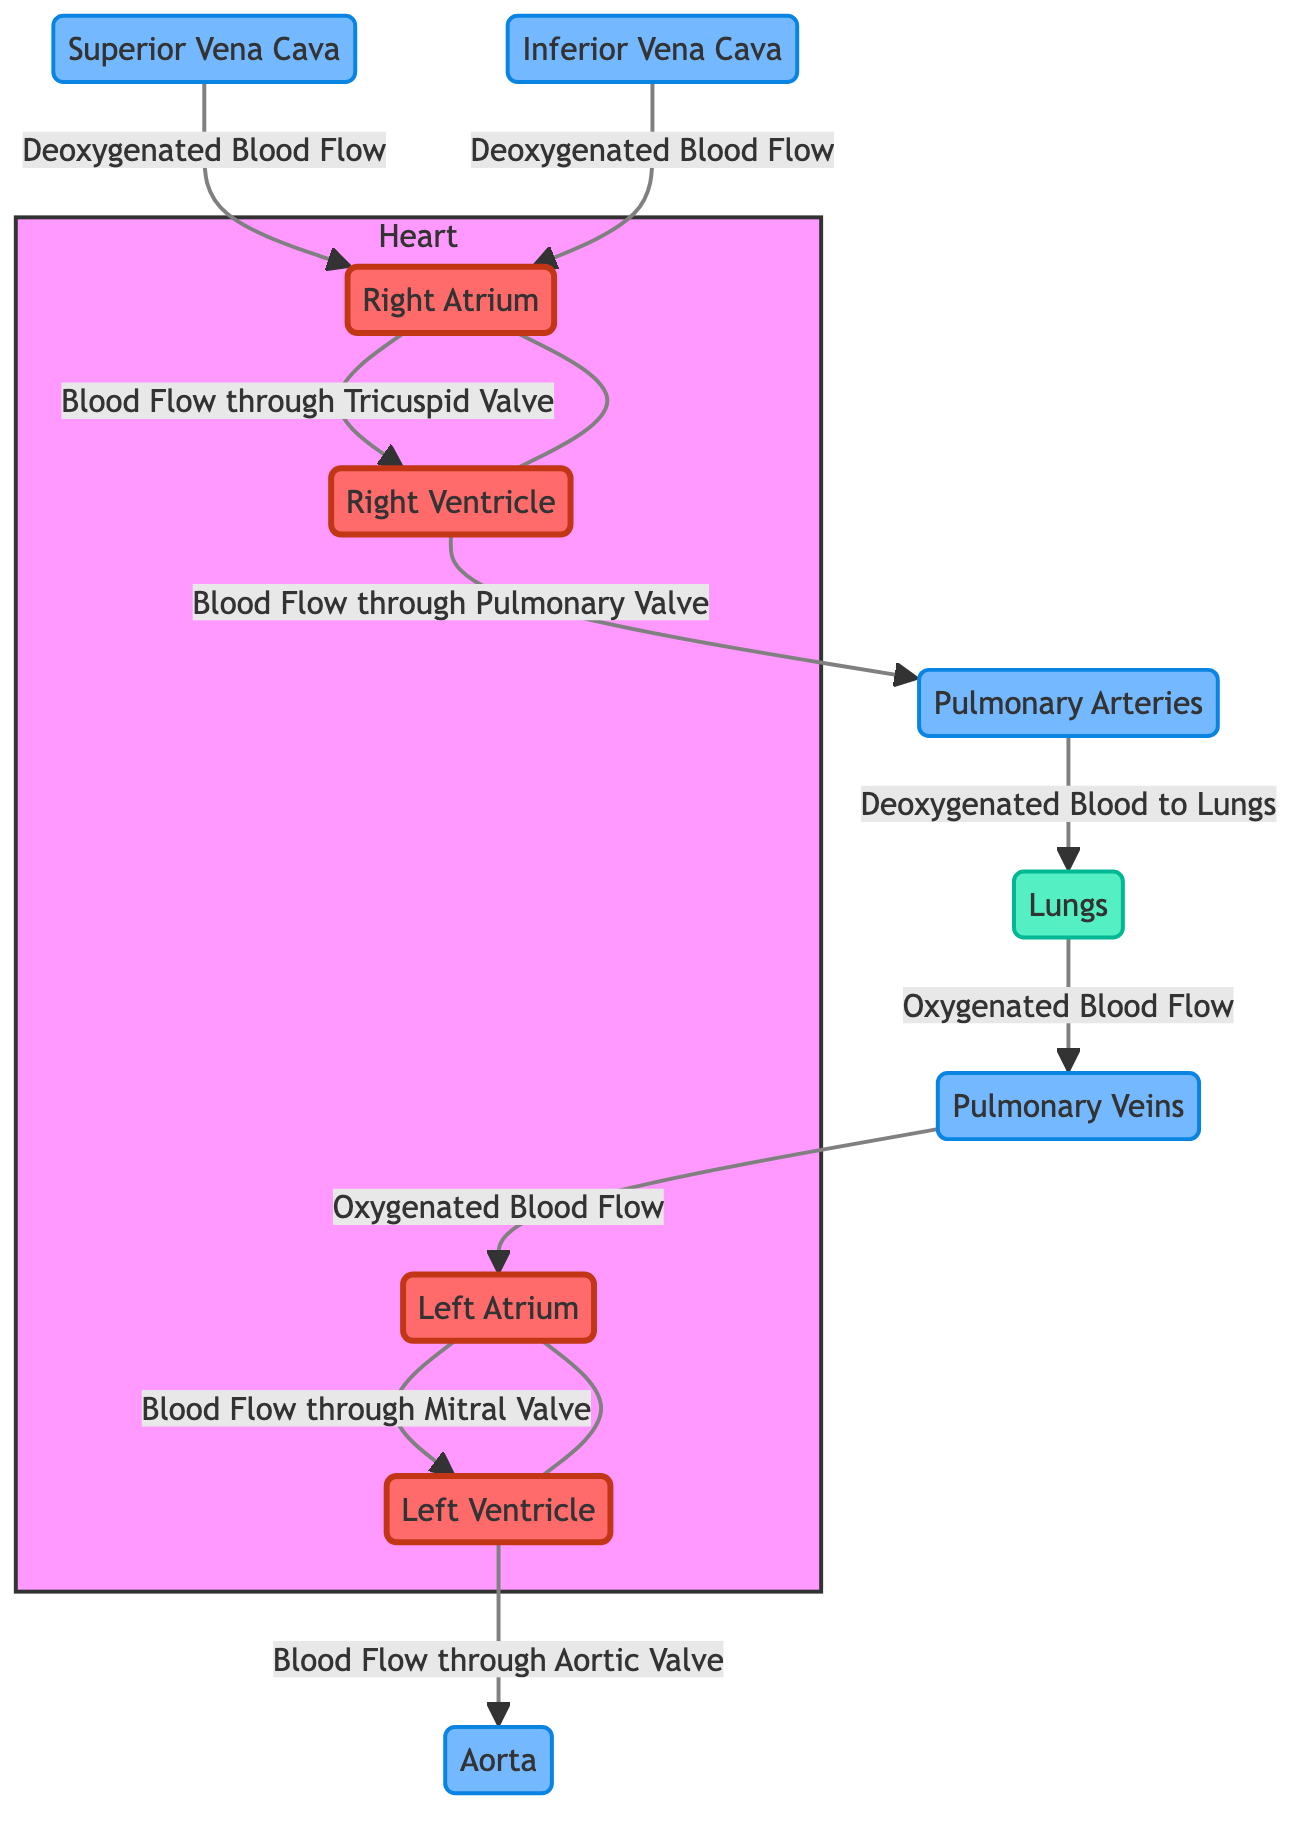What structures provide deoxygenated blood to the right atrium? The diagram shows the superior vena cava and the inferior vena cava both leading into the right atrium, indicating they bring deoxygenated blood from the body.
Answer: Superior Vena Cava, Inferior Vena Cava Which valve does blood flow through from the right atrium to the right ventricle? The diagram indicates that blood flows from the right atrium to the right ventricle through the tricuspid valve, as labeled in the diagram.
Answer: Tricuspid Valve How many major chambers are visible in the diagram? The diagram depicts four major heart chambers: right atrium, right ventricle, left atrium, and left ventricle. Counting these gives a total of four chambers.
Answer: Four What is the pathway of oxygenated blood from the lungs to the left atrium? The diagram illustrates that oxygenated blood flows from the lungs to the pulmonary veins and then into the left atrium, linking these two nodes directly in sequence.
Answer: Lungs → Pulmonary Veins → Left Atrium What type of blood enters the pulmonary arteries? According to the diagram, the pulmonary arteries receive deoxygenated blood from the right ventricle for transport to the lungs for oxygenation, as indicated in the labeled pathways.
Answer: Deoxygenated Blood Which valve does blood pass through when moving from the left ventricle to the aorta? The flowchart specifies that blood exits the left ventricle through the aortic valve, as shown by the directional flow in the diagram.
Answer: Aortic Valve Describe the location of the pulmonary veins in the flowchart. In the diagram, the pulmonary veins are positioned between the lungs and the left atrium, linking these two structures and indicating their role in transporting oxygenated blood.
Answer: Between Lungs and Left Atrium What is the first point of entry for deoxygenated blood into the heart? The diagram shows that deoxygenated blood first enters the right atrium via the superior and inferior vena cavae, thus making the right atrium the initial entry point for deoxygenated blood.
Answer: Right Atrium 